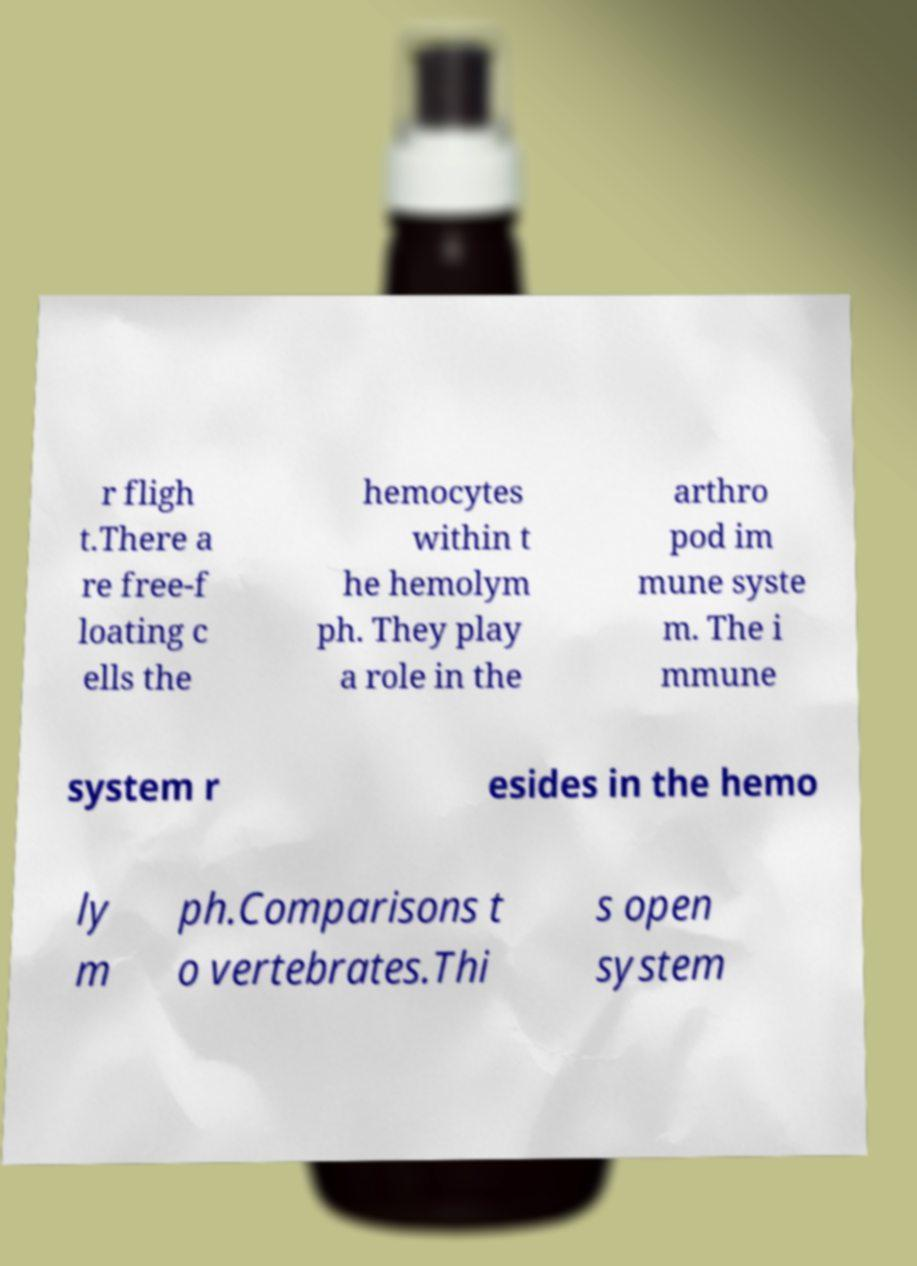Can you read and provide the text displayed in the image?This photo seems to have some interesting text. Can you extract and type it out for me? r fligh t.There a re free-f loating c ells the hemocytes within t he hemolym ph. They play a role in the arthro pod im mune syste m. The i mmune system r esides in the hemo ly m ph.Comparisons t o vertebrates.Thi s open system 